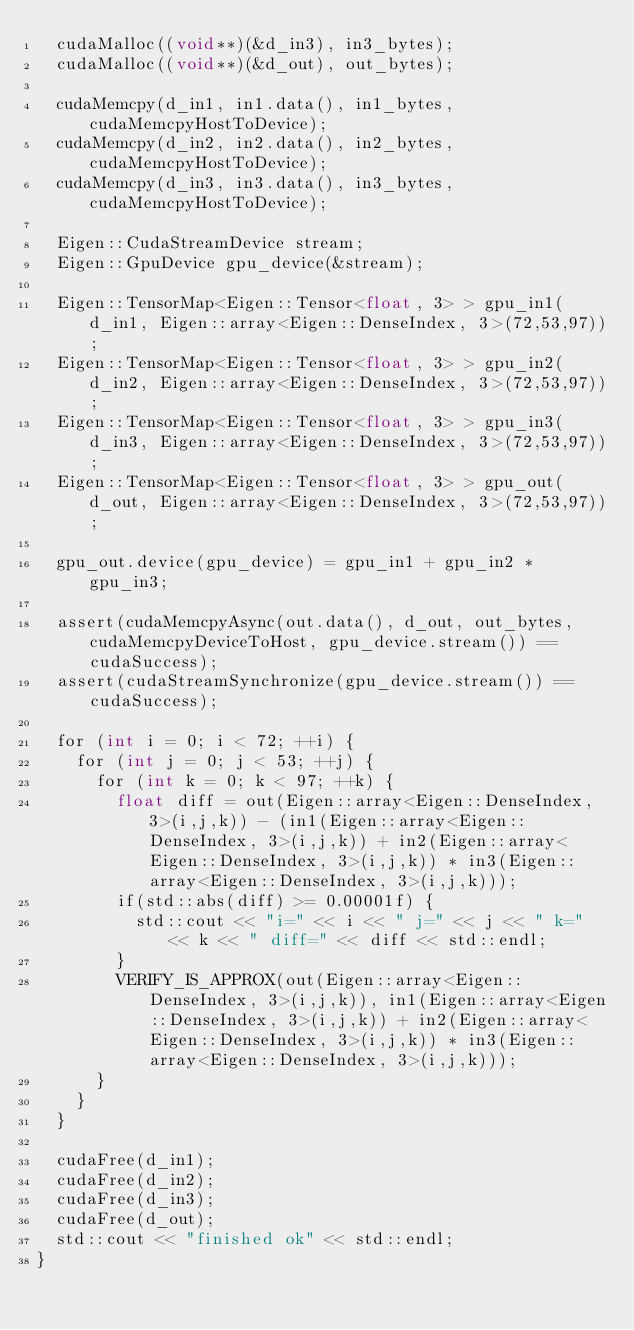<code> <loc_0><loc_0><loc_500><loc_500><_Cuda_>  cudaMalloc((void**)(&d_in3), in3_bytes);
  cudaMalloc((void**)(&d_out), out_bytes);

  cudaMemcpy(d_in1, in1.data(), in1_bytes, cudaMemcpyHostToDevice);
  cudaMemcpy(d_in2, in2.data(), in2_bytes, cudaMemcpyHostToDevice);
  cudaMemcpy(d_in3, in3.data(), in3_bytes, cudaMemcpyHostToDevice);

  Eigen::CudaStreamDevice stream;
  Eigen::GpuDevice gpu_device(&stream);

  Eigen::TensorMap<Eigen::Tensor<float, 3> > gpu_in1(d_in1, Eigen::array<Eigen::DenseIndex, 3>(72,53,97));
  Eigen::TensorMap<Eigen::Tensor<float, 3> > gpu_in2(d_in2, Eigen::array<Eigen::DenseIndex, 3>(72,53,97));
  Eigen::TensorMap<Eigen::Tensor<float, 3> > gpu_in3(d_in3, Eigen::array<Eigen::DenseIndex, 3>(72,53,97));
  Eigen::TensorMap<Eigen::Tensor<float, 3> > gpu_out(d_out, Eigen::array<Eigen::DenseIndex, 3>(72,53,97));

  gpu_out.device(gpu_device) = gpu_in1 + gpu_in2 * gpu_in3;

  assert(cudaMemcpyAsync(out.data(), d_out, out_bytes, cudaMemcpyDeviceToHost, gpu_device.stream()) == cudaSuccess);
  assert(cudaStreamSynchronize(gpu_device.stream()) == cudaSuccess);

  for (int i = 0; i < 72; ++i) {
    for (int j = 0; j < 53; ++j) {
      for (int k = 0; k < 97; ++k) {
        float diff = out(Eigen::array<Eigen::DenseIndex, 3>(i,j,k)) - (in1(Eigen::array<Eigen::DenseIndex, 3>(i,j,k)) + in2(Eigen::array<Eigen::DenseIndex, 3>(i,j,k)) * in3(Eigen::array<Eigen::DenseIndex, 3>(i,j,k)));
        if(std::abs(diff) >= 0.00001f) {
          std::cout << "i=" << i << " j=" << j << " k=" << k << " diff=" << diff << std::endl;
        }
        VERIFY_IS_APPROX(out(Eigen::array<Eigen::DenseIndex, 3>(i,j,k)), in1(Eigen::array<Eigen::DenseIndex, 3>(i,j,k)) + in2(Eigen::array<Eigen::DenseIndex, 3>(i,j,k)) * in3(Eigen::array<Eigen::DenseIndex, 3>(i,j,k)));
      }
    }
  }

  cudaFree(d_in1);
  cudaFree(d_in2);
  cudaFree(d_in3);
  cudaFree(d_out);
  std::cout << "finished ok" << std::endl;
}
</code> 